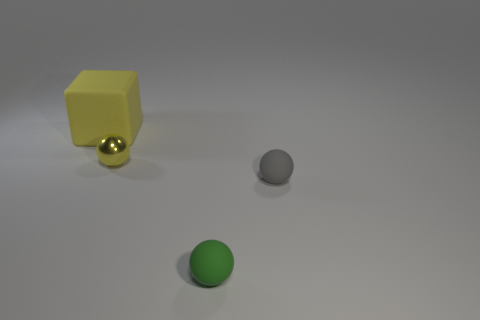Are there any other small spheres that have the same material as the yellow ball?
Make the answer very short. No. What number of cubes are either tiny yellow objects or matte things?
Give a very brief answer. 1. Are there any green matte things that are left of the yellow object that is on the left side of the yellow shiny ball?
Ensure brevity in your answer.  No. Is the number of tiny green matte objects less than the number of small purple metal cylinders?
Offer a terse response. No. How many large rubber objects have the same shape as the small green thing?
Ensure brevity in your answer.  0. How many yellow things are either tiny metal things or tiny objects?
Your answer should be compact. 1. There is a yellow rubber cube behind the green matte ball that is to the right of the yellow shiny ball; what is its size?
Ensure brevity in your answer.  Large. There is a small yellow thing that is the same shape as the gray thing; what is it made of?
Your answer should be compact. Metal. What number of other balls are the same size as the yellow ball?
Your answer should be very brief. 2. Do the gray ball and the yellow matte block have the same size?
Your response must be concise. No. 